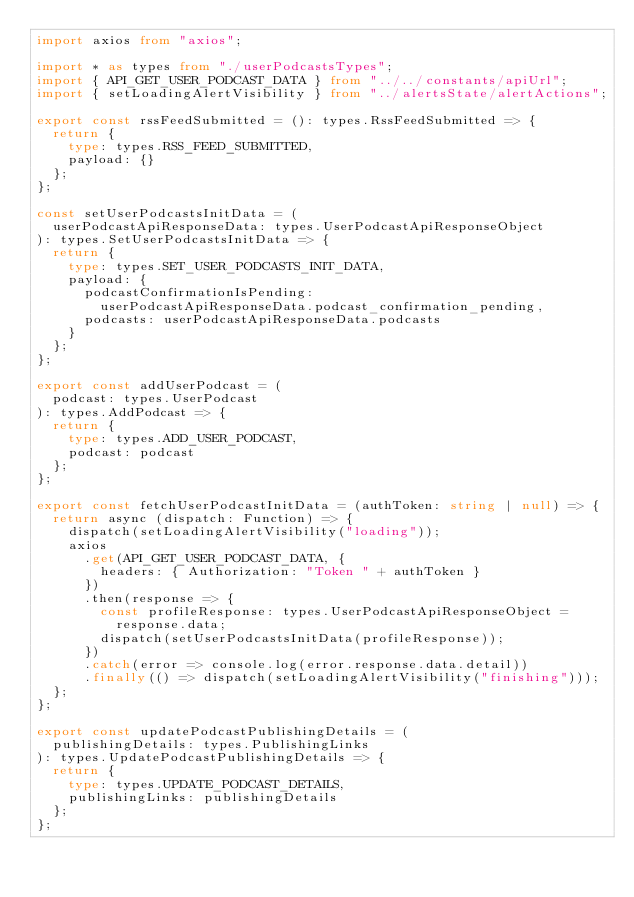Convert code to text. <code><loc_0><loc_0><loc_500><loc_500><_TypeScript_>import axios from "axios";

import * as types from "./userPodcastsTypes";
import { API_GET_USER_PODCAST_DATA } from "../../constants/apiUrl";
import { setLoadingAlertVisibility } from "../alertsState/alertActions";

export const rssFeedSubmitted = (): types.RssFeedSubmitted => {
  return {
    type: types.RSS_FEED_SUBMITTED,
    payload: {}
  };
};

const setUserPodcastsInitData = (
  userPodcastApiResponseData: types.UserPodcastApiResponseObject
): types.SetUserPodcastsInitData => {
  return {
    type: types.SET_USER_PODCASTS_INIT_DATA,
    payload: {
      podcastConfirmationIsPending:
        userPodcastApiResponseData.podcast_confirmation_pending,
      podcasts: userPodcastApiResponseData.podcasts
    }
  };
};

export const addUserPodcast = (
  podcast: types.UserPodcast
): types.AddPodcast => {
  return {
    type: types.ADD_USER_PODCAST,
    podcast: podcast
  };
};

export const fetchUserPodcastInitData = (authToken: string | null) => {
  return async (dispatch: Function) => {
    dispatch(setLoadingAlertVisibility("loading"));
    axios
      .get(API_GET_USER_PODCAST_DATA, {
        headers: { Authorization: "Token " + authToken }
      })
      .then(response => {
        const profileResponse: types.UserPodcastApiResponseObject =
          response.data;
        dispatch(setUserPodcastsInitData(profileResponse));
      })
      .catch(error => console.log(error.response.data.detail))
      .finally(() => dispatch(setLoadingAlertVisibility("finishing")));
  };
};

export const updatePodcastPublishingDetails = (
  publishingDetails: types.PublishingLinks
): types.UpdatePodcastPublishingDetails => {
  return {
    type: types.UPDATE_PODCAST_DETAILS,
    publishingLinks: publishingDetails
  };
};
</code> 